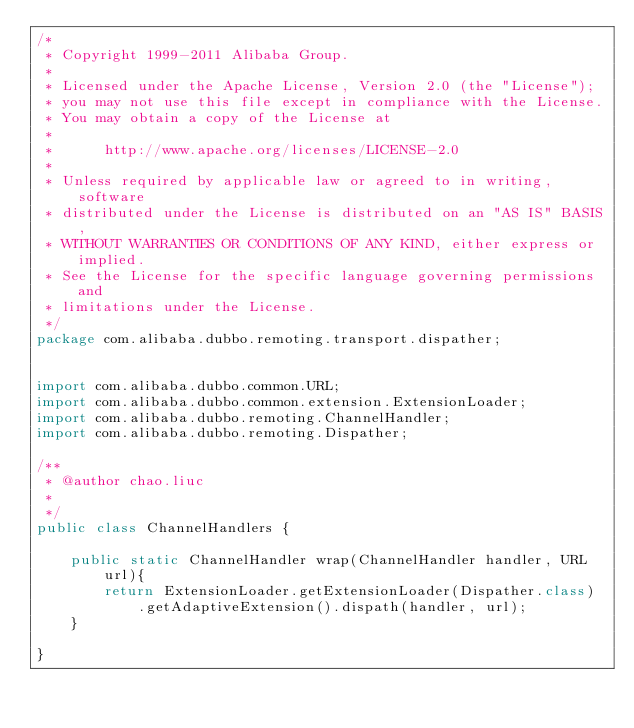<code> <loc_0><loc_0><loc_500><loc_500><_Java_>/*
 * Copyright 1999-2011 Alibaba Group.
 *  
 * Licensed under the Apache License, Version 2.0 (the "License");
 * you may not use this file except in compliance with the License.
 * You may obtain a copy of the License at
 *  
 *      http://www.apache.org/licenses/LICENSE-2.0
 *  
 * Unless required by applicable law or agreed to in writing, software
 * distributed under the License is distributed on an "AS IS" BASIS,
 * WITHOUT WARRANTIES OR CONDITIONS OF ANY KIND, either express or implied.
 * See the License for the specific language governing permissions and
 * limitations under the License.
 */
package com.alibaba.dubbo.remoting.transport.dispather;


import com.alibaba.dubbo.common.URL;
import com.alibaba.dubbo.common.extension.ExtensionLoader;
import com.alibaba.dubbo.remoting.ChannelHandler;
import com.alibaba.dubbo.remoting.Dispather;

/**
 * @author chao.liuc
 *
 */
public class ChannelHandlers {

    public static ChannelHandler wrap(ChannelHandler handler, URL url){
        return ExtensionLoader.getExtensionLoader(Dispather.class)
            .getAdaptiveExtension().dispath(handler, url);
    }

}</code> 